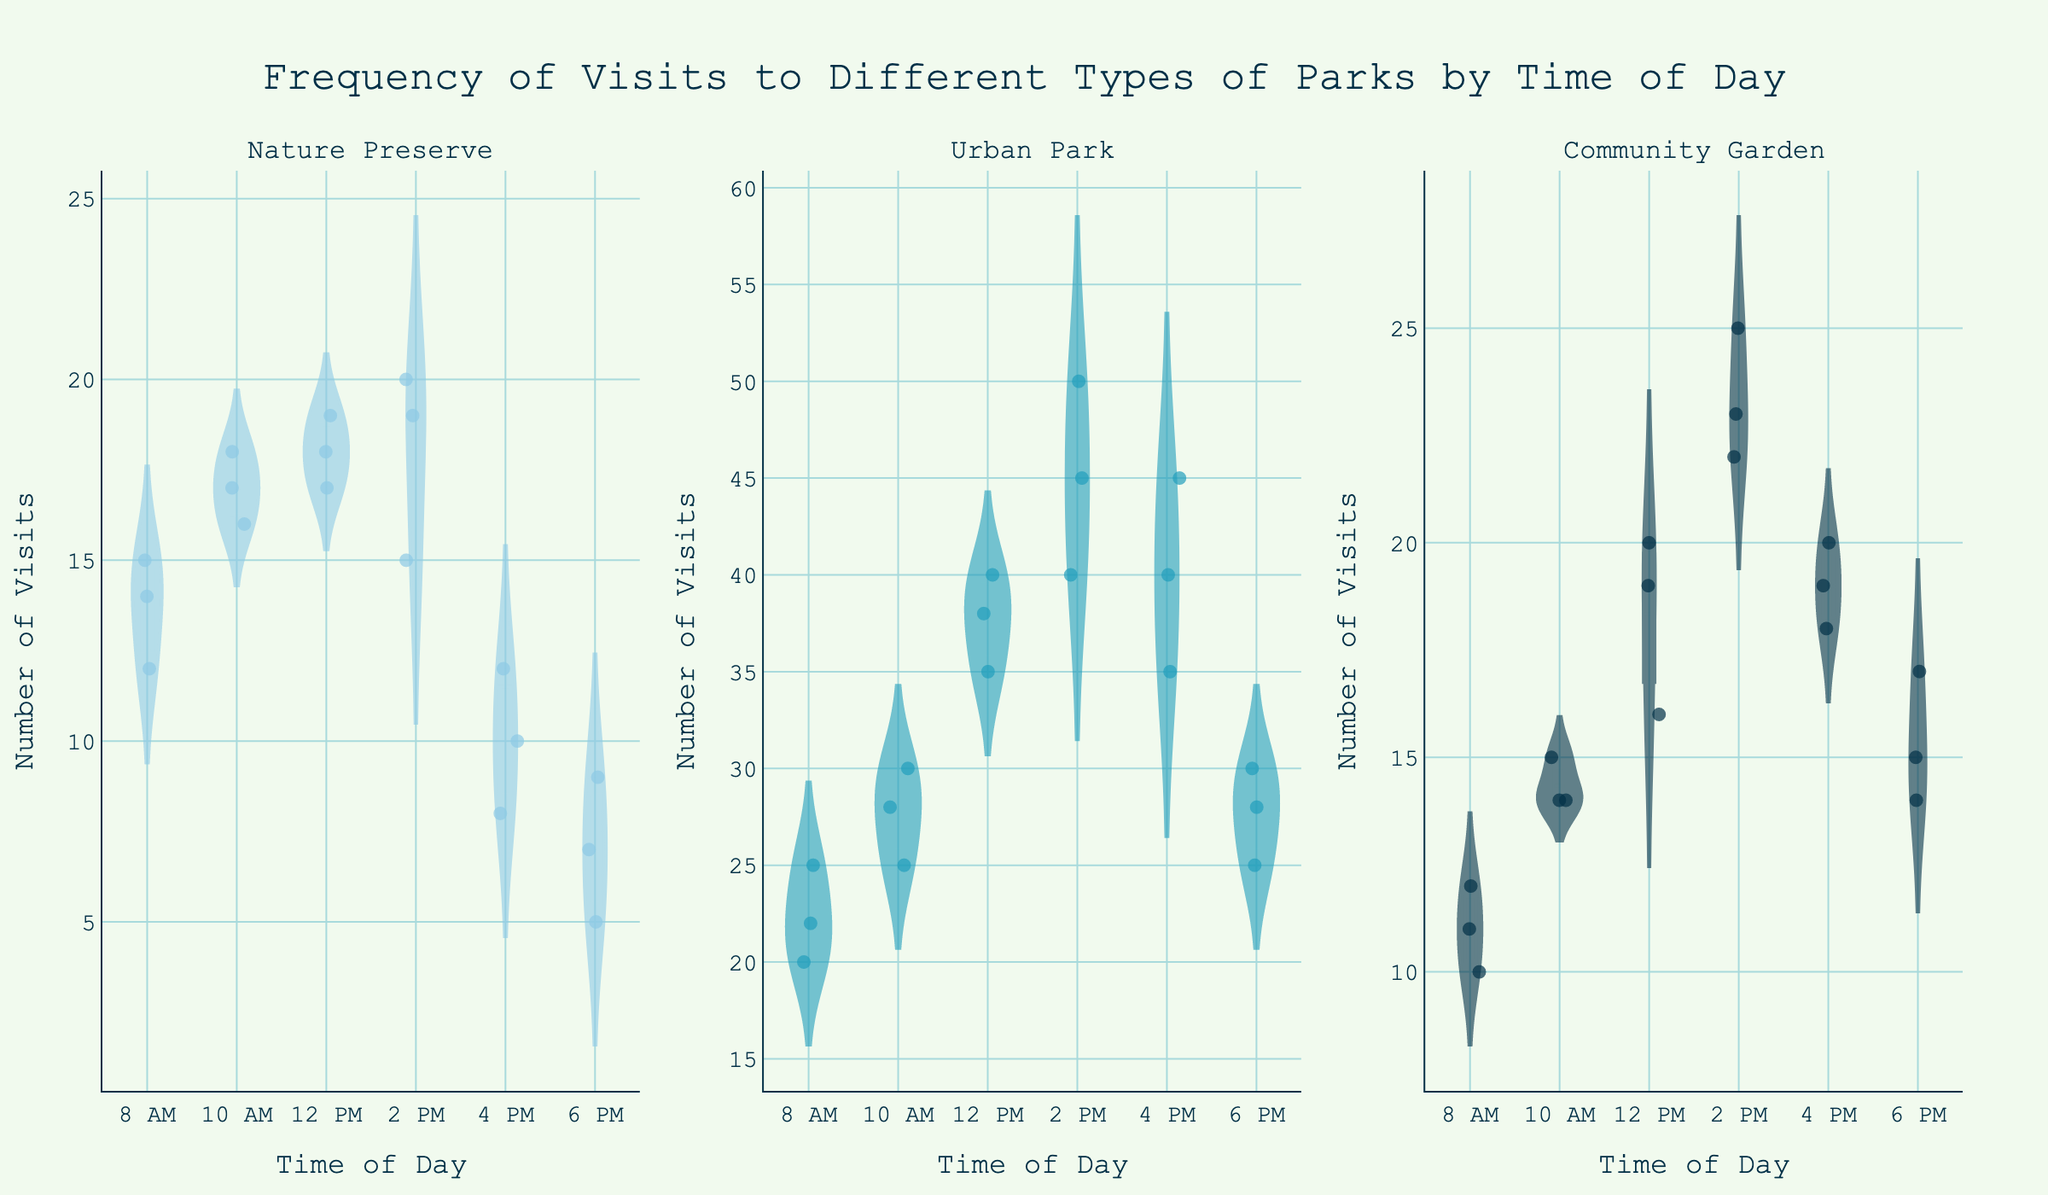what is the title of the chart? The title is located at the top center of the figure and describes the main subject. Read it directly from the figure.
Answer: Frequency of Visits to Different Types of Parks by Time of Day what are the three types of parks shown in the chart? The types of parks are displayed as individual subplot titles. Look at each subplot to identify them.
Answer: Nature Preserve, Urban Park, Community Garden what times of day are included in the data? The time range is depicted as tick labels on the x-axis of each subplot. Reference the labels to identify the times shown.
Answer: 8 AM, 10 AM, 12 PM, 2 PM, 4 PM, 6 PM what is the general trend in visits to urban parks as the day progresses? Observe the violin plot and jittered points in the Urban Park subplot. Notice how the number of visits changes from morning to evening.
Answer: Visits increase from morning until 2 PM, then decrease for community gardens, how does the number of visits at 12 PM on Monday compare to 12 PM on Tuesday? Look at the jittered points and the data density around 12 PM on both days in the Community Garden subplot. Count or estimate the number at these points.
Answer: 20 on Monday, 16 on Tuesday which time slot has the highest median number of visits for nature preserves? In the Nature Preserve subplot, check the median line (horizontal line inside the violin plot) for each time slot and identify the highest one.
Answer: 2 PM considering all park types, which has the largest range of visits at 12 PM? Compare the length of the violins at 12 PM for each park type to see which one spans the widest range.
Answer: Urban Park how do the visit patterns differ between urban parks and community gardens? Analyze the violin shapes and jittered points distribution in both Urban Park and Community Garden subplots. Note differences in visit trends and variability through the day.
Answer: Urban Parks have higher visits with increased variability; Community Gardens have moderate, more consistent visits how does the consistency of visits at nature preserves in the evening compare to the morning? Examine the spread and density of the jittered points and the width of the violins at morning and evening times in the Nature Preserve subplot. Compare how tightly packed the points are.
Answer: Evening visits are less consistent which park type shows the most distinct increase in visits during midday (between 10 AM and 2 PM)? Observe the change in density and vertical range of the violin plots between 10 AM and 2 PM for each park type. Identify which shows the steepest increase.
Answer: Urban Park 